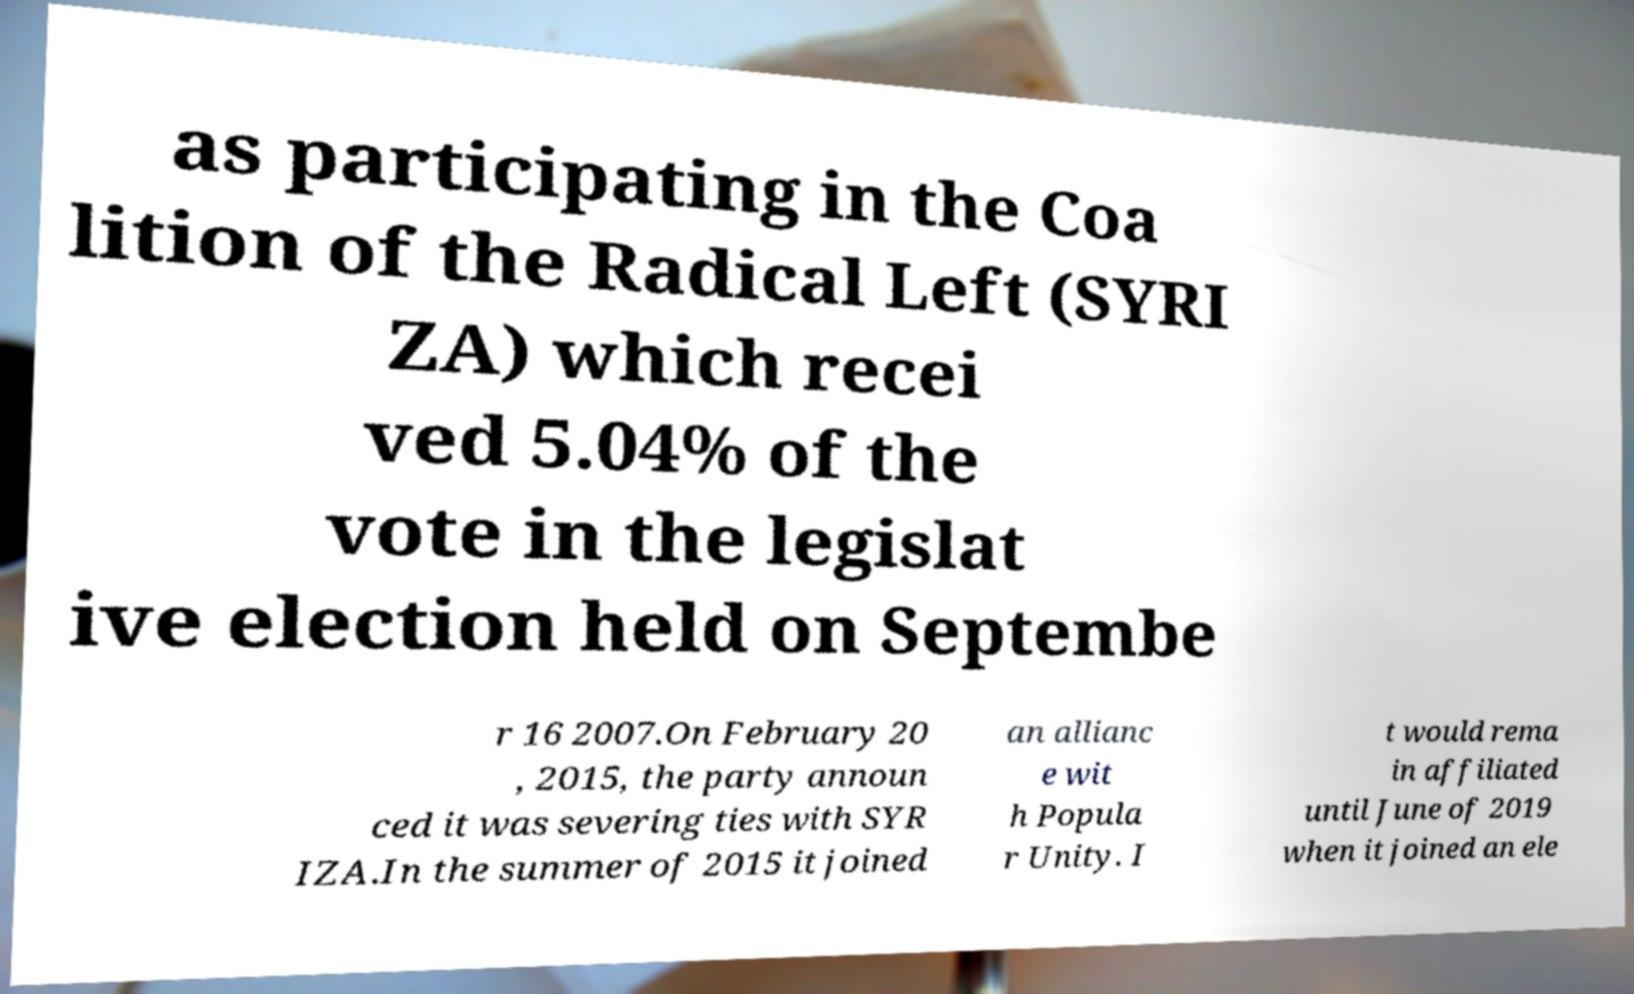For documentation purposes, I need the text within this image transcribed. Could you provide that? as participating in the Coa lition of the Radical Left (SYRI ZA) which recei ved 5.04% of the vote in the legislat ive election held on Septembe r 16 2007.On February 20 , 2015, the party announ ced it was severing ties with SYR IZA.In the summer of 2015 it joined an allianc e wit h Popula r Unity. I t would rema in affiliated until June of 2019 when it joined an ele 